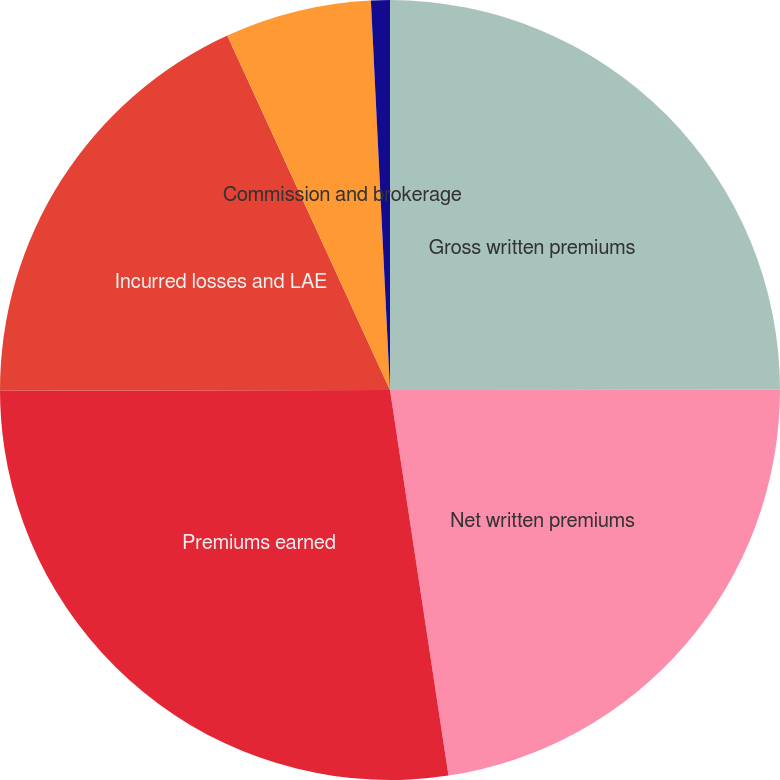Convert chart. <chart><loc_0><loc_0><loc_500><loc_500><pie_chart><fcel>Gross written premiums<fcel>Net written premiums<fcel>Premiums earned<fcel>Incurred losses and LAE<fcel>Commission and brokerage<fcel>Other underwriting expenses<nl><fcel>24.99%<fcel>22.62%<fcel>27.37%<fcel>18.18%<fcel>6.07%<fcel>0.78%<nl></chart> 